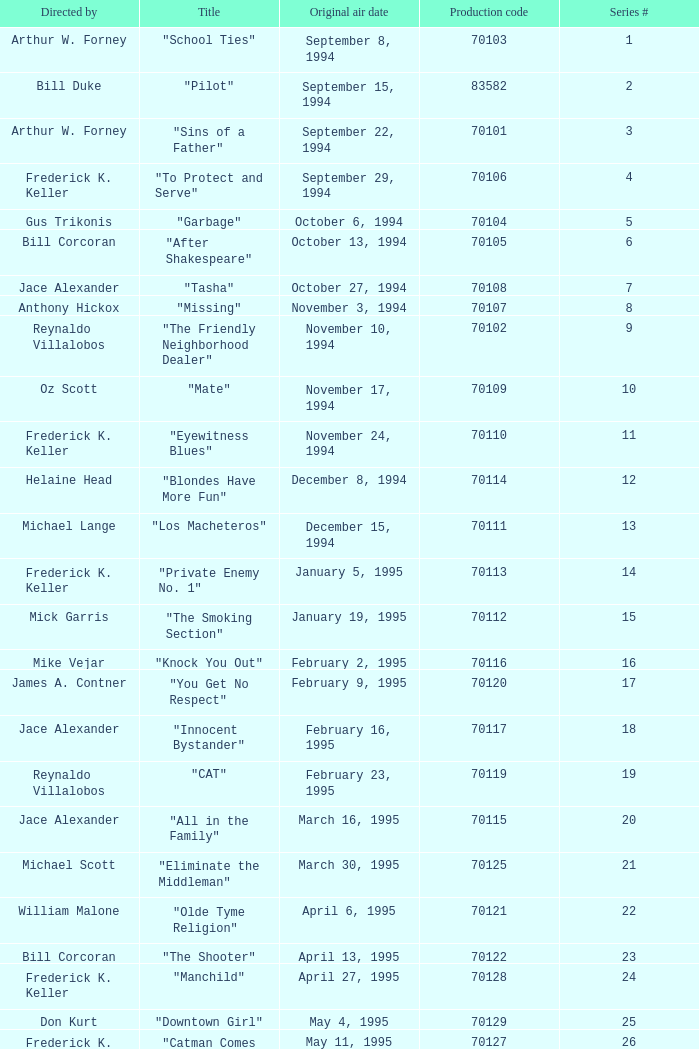For the "Downtown Girl" episode, what was the original air date? May 4, 1995. 